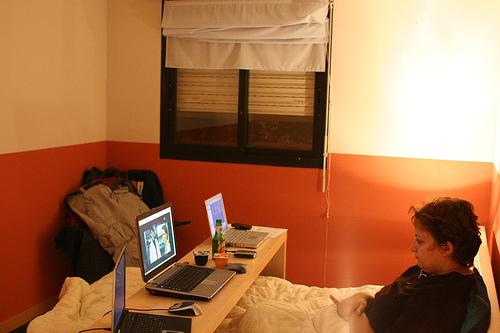What is the number of laptops sat on the bar held over this bed?

Choices:
A) six
B) five
C) four
D) three three 